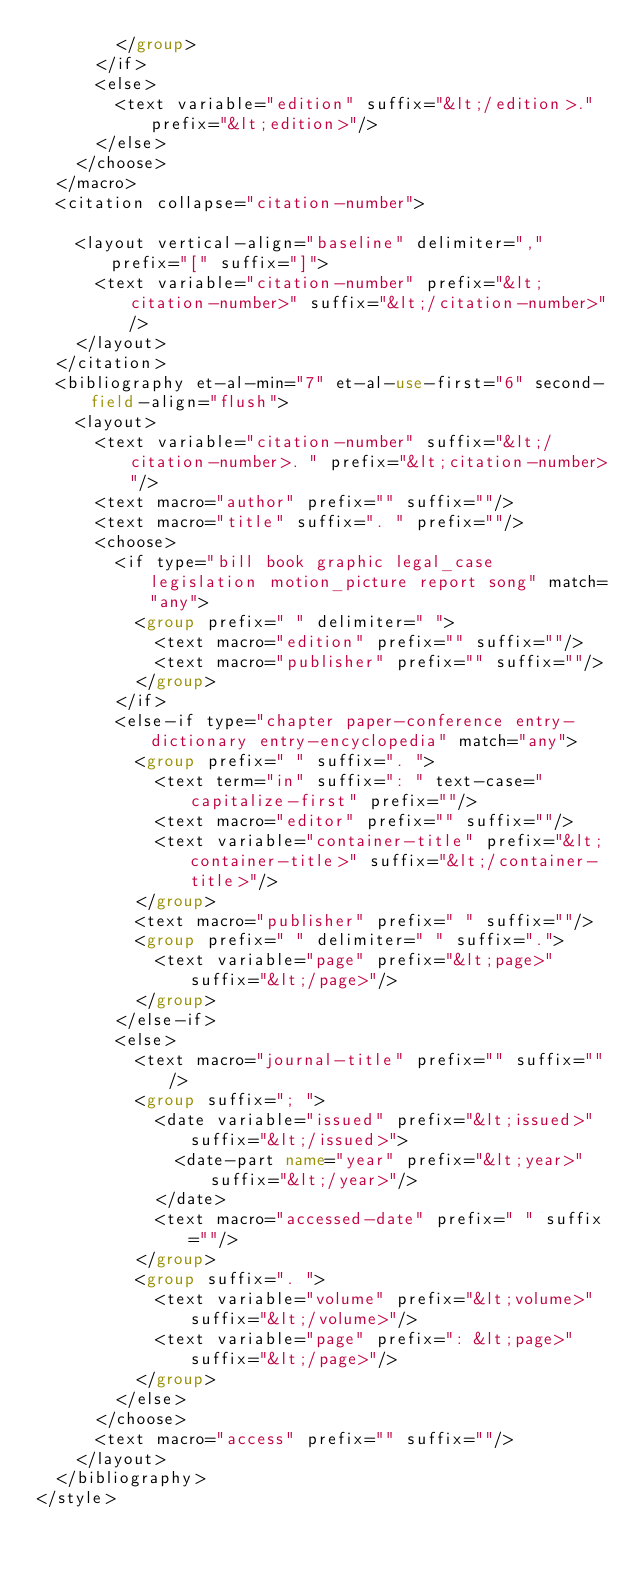Convert code to text. <code><loc_0><loc_0><loc_500><loc_500><_XML_>        </group>
      </if>
      <else>
        <text variable="edition" suffix="&lt;/edition>." prefix="&lt;edition>"/>
      </else>
    </choose>
  </macro>
  <citation collapse="citation-number">
    
    <layout vertical-align="baseline" delimiter="," prefix="[" suffix="]">
      <text variable="citation-number" prefix="&lt;citation-number>" suffix="&lt;/citation-number>"/>
    </layout>
  </citation>
  <bibliography et-al-min="7" et-al-use-first="6" second-field-align="flush">
    <layout>
      <text variable="citation-number" suffix="&lt;/citation-number>. " prefix="&lt;citation-number>"/>
      <text macro="author" prefix="" suffix=""/>
      <text macro="title" suffix=". " prefix=""/>
      <choose>
        <if type="bill book graphic legal_case legislation motion_picture report song" match="any">
          <group prefix=" " delimiter=" ">
            <text macro="edition" prefix="" suffix=""/>
            <text macro="publisher" prefix="" suffix=""/>
          </group>
        </if>
        <else-if type="chapter paper-conference entry-dictionary entry-encyclopedia" match="any">
          <group prefix=" " suffix=". ">
            <text term="in" suffix=": " text-case="capitalize-first" prefix=""/>
            <text macro="editor" prefix="" suffix=""/>
            <text variable="container-title" prefix="&lt;container-title>" suffix="&lt;/container-title>"/>
          </group>
          <text macro="publisher" prefix=" " suffix=""/>
          <group prefix=" " delimiter=" " suffix=".">
            <text variable="page" prefix="&lt;page>" suffix="&lt;/page>"/>
          </group>
        </else-if>
        <else>
          <text macro="journal-title" prefix="" suffix=""/>
          <group suffix="; ">
            <date variable="issued" prefix="&lt;issued>" suffix="&lt;/issued>">
              <date-part name="year" prefix="&lt;year>" suffix="&lt;/year>"/>
            </date>
            <text macro="accessed-date" prefix=" " suffix=""/>
          </group>
          <group suffix=". ">
            <text variable="volume" prefix="&lt;volume>" suffix="&lt;/volume>"/>
            <text variable="page" prefix=": &lt;page>" suffix="&lt;/page>"/>
          </group>
        </else>
      </choose>
      <text macro="access" prefix="" suffix=""/>
    </layout>
  </bibliography>
</style></code> 